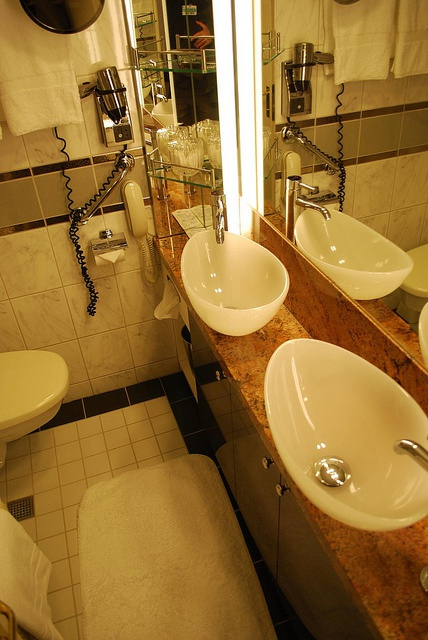Describe the objects in this image and their specific colors. I can see sink in olive, tan, and orange tones, sink in olive, tan, and brown tones, toilet in olive, tan, and orange tones, and hair drier in olive, black, and maroon tones in this image. 